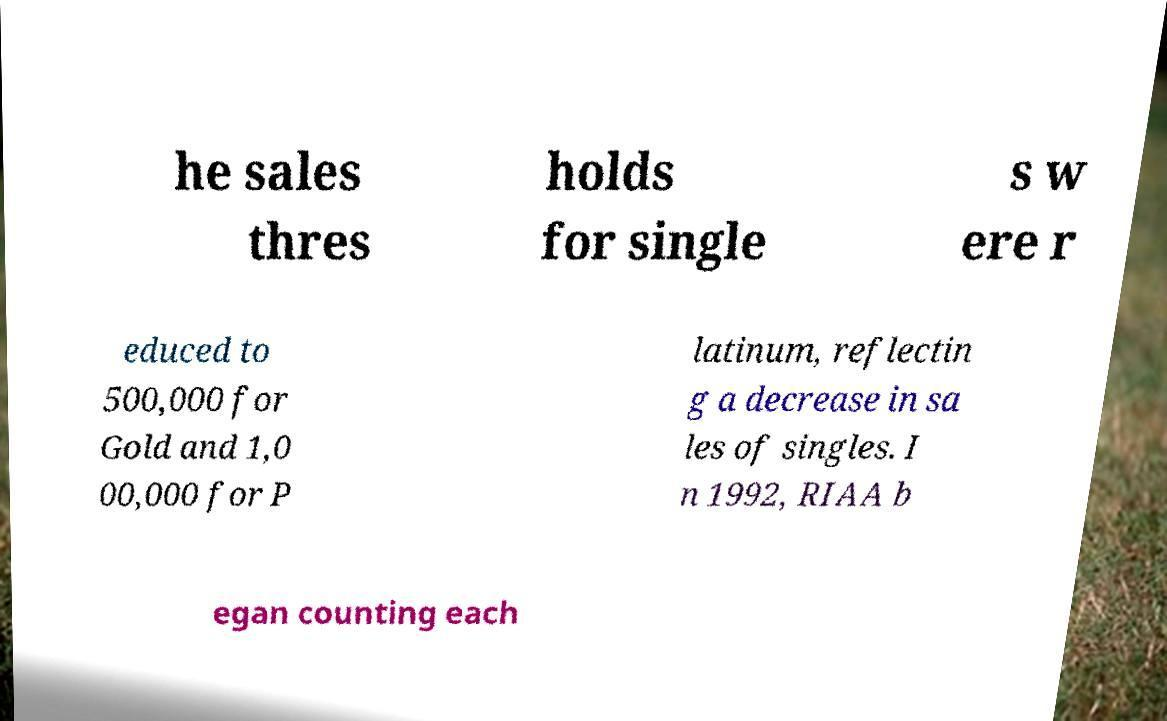Please identify and transcribe the text found in this image. he sales thres holds for single s w ere r educed to 500,000 for Gold and 1,0 00,000 for P latinum, reflectin g a decrease in sa les of singles. I n 1992, RIAA b egan counting each 